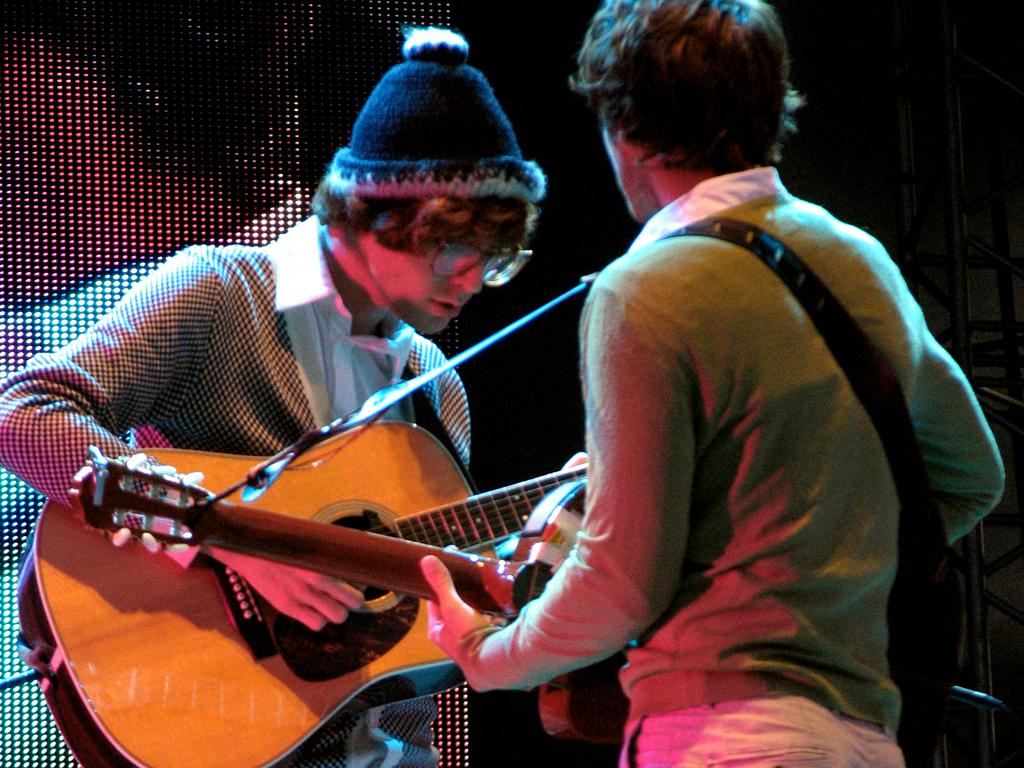How many people are in the image? There are two persons in the image. What is one of the persons wearing? One of the persons is wearing a cap. What activity are both persons engaged in? Both persons are playing a guitar. What grade does the person with the cap receive for their guitar playing in the image? There is no indication of a grade or evaluation in the image, so it cannot be determined. 